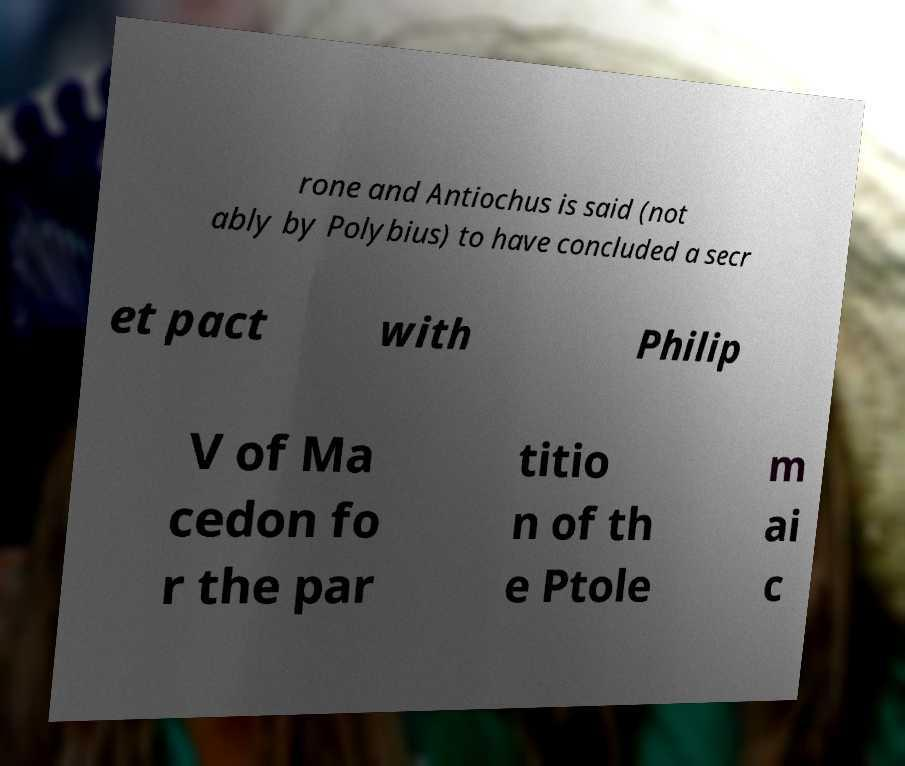What messages or text are displayed in this image? I need them in a readable, typed format. rone and Antiochus is said (not ably by Polybius) to have concluded a secr et pact with Philip V of Ma cedon fo r the par titio n of th e Ptole m ai c 